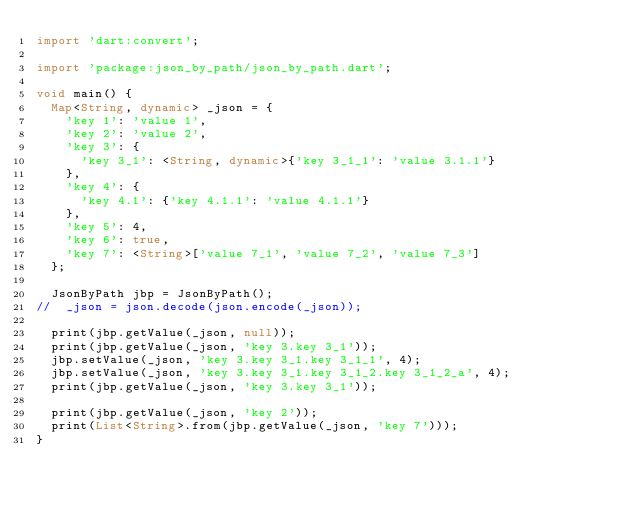<code> <loc_0><loc_0><loc_500><loc_500><_Dart_>import 'dart:convert';

import 'package:json_by_path/json_by_path.dart';

void main() {
  Map<String, dynamic> _json = {
    'key 1': 'value 1',
    'key 2': 'value 2',
    'key 3': {
      'key 3_1': <String, dynamic>{'key 3_1_1': 'value 3.1.1'}
    },
    'key 4': {
      'key 4.1': {'key 4.1.1': 'value 4.1.1'}
    },
    'key 5': 4,
    'key 6': true,
    'key 7': <String>['value 7_1', 'value 7_2', 'value 7_3']
  };

  JsonByPath jbp = JsonByPath();
//  _json = json.decode(json.encode(_json));

  print(jbp.getValue(_json, null));
  print(jbp.getValue(_json, 'key 3.key 3_1'));
  jbp.setValue(_json, 'key 3.key 3_1.key 3_1_1', 4);
  jbp.setValue(_json, 'key 3.key 3_1.key 3_1_2.key 3_1_2_a', 4);
  print(jbp.getValue(_json, 'key 3.key 3_1'));

  print(jbp.getValue(_json, 'key 2'));
  print(List<String>.from(jbp.getValue(_json, 'key 7')));
}
</code> 